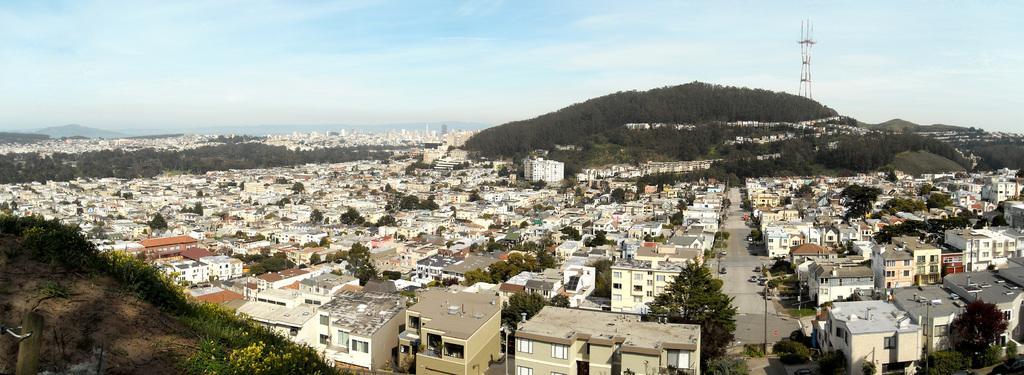Could you give a brief overview of what you see in this image? This is the picture of a city. In this image there are buildings and trees. At the back there are mountains and there is a tower. In the foreground there are poles, there are vehicles on the road and there are flowers, plants. At the top there is sky and there are clouds. 